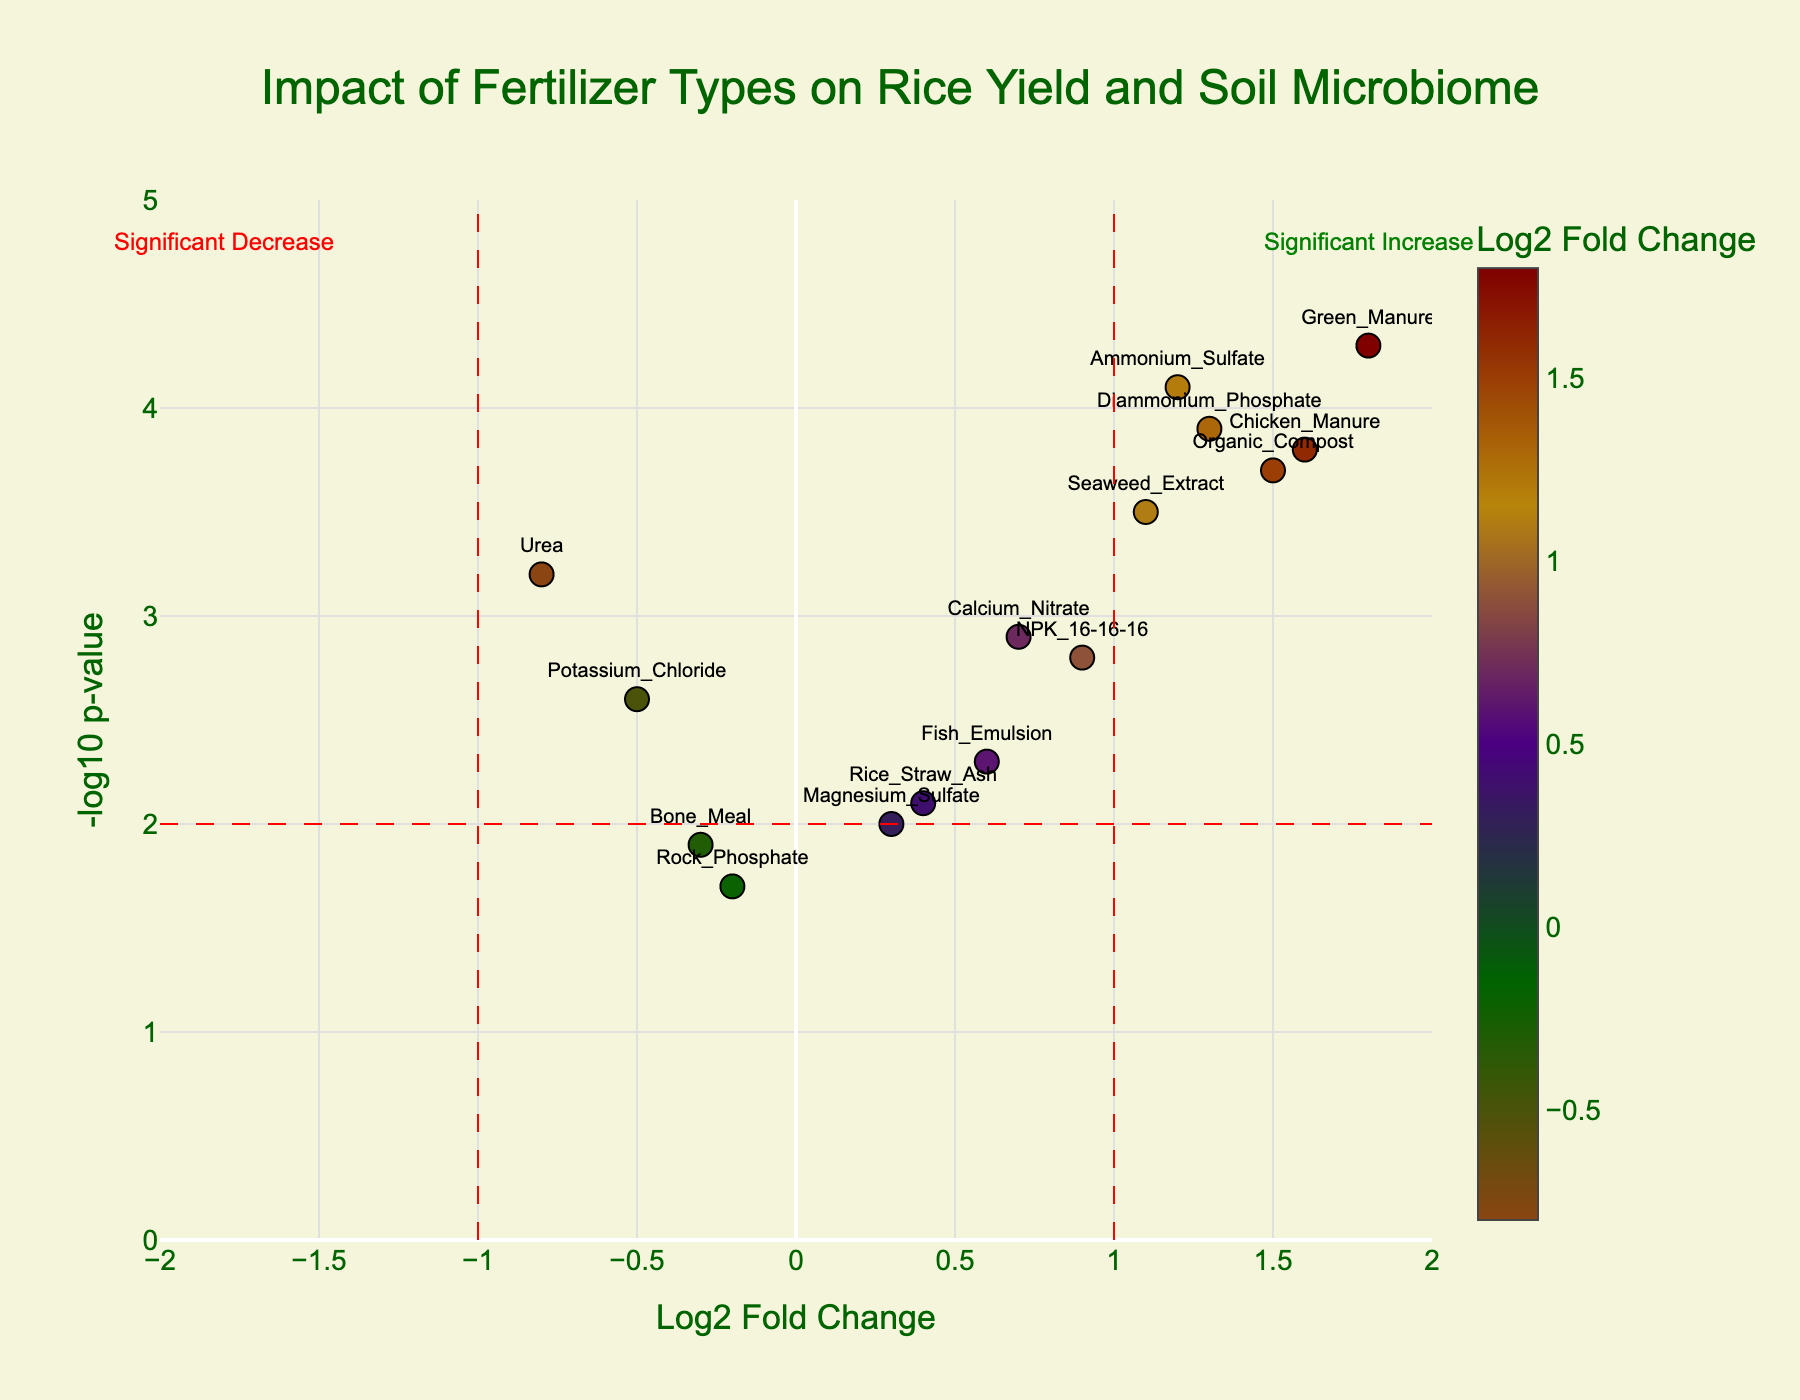How many fertilizer types are shown in the figure? Count each label for the data points listed in the figure. There are 15 different fertilizers mentioned.
Answer: 15 What fertilizer type shows the highest log2 fold change? Observe the x-axis values and find the data point furthest to the right. "Green Manure" has the highest log2 fold change at 1.8.
Answer: Green Manure Which fertilizer type has the lowest -log10 p-value? Notice the y-axis and find the lowest positioned data point. "Rock Phosphate" has the lowest -log10 p-value at 1.7.
Answer: Rock Phosphate Identify which fertilizers showed a significant increase in response. Check the data points on the right side of the vertical red line at x=1. Fertilizers with log2 fold change greater than 1 and significant p-values (above the horizontal red line at y=2) are "Ammonium Sulfate," "Diammonium Phosphate," "Green Manure," "Chicken Manure."
Answer: Ammonium Sulfate, Diammonium Phosphate, Green Manure, Chicken Manure Do any fertilizers show a significant decrease in response? Look for data points left of the vertical red line at x=-1 and above the horizontal red line at y=2. No fertilizers meet these criteria.
Answer: No Compare the log2 fold change between “Organic Compost” and “Urea.” Which one had a higher value? From the plot, find the log2 fold change values for "Organic Compost" which is 1.5, and "Urea" which is -0.8. "Organic Compost" has the higher value.
Answer: Organic Compost What is the p-value significance threshold displayed in the plot? The horizontal red dashed line that runs across the figure represents the threshold, which is indicated at a y value of 2.
Answer: 2 Which fertilizer types are considered statistically significant in terms of p-value? Identify fertilizer types whose data points are above the horizontal red line at y=2. The significant ones are: "Urea," "Ammonium Sulfate," "NPK 16-16-16," "Organic Compost," "Seaweed Extract," "Diammonium Phosphate," "Green Manure," "Chicken Manure," "Potassium Chloride," and "Calcium Nitrate."
Answer: Urea, Ammonium Sulfate, NPK 16-16-16, Organic Compost, Seaweed Extract, Diammonium Phosphate, Green Manure, Chicken Manure, Potassium Chloride, Calcium Nitrate Which fertilizer type has a log2 fold change closest to 0? Locate data points near the x=0 line and find the data point closest to it. "Rock Phosphate" has a log2 fold change of -0.2, which is closest to 0.
Answer: Rock Phosphate 